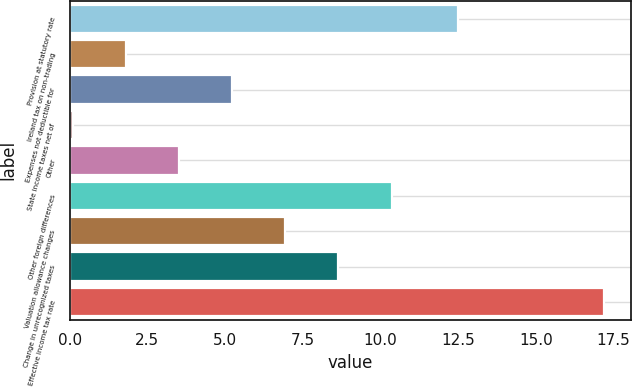<chart> <loc_0><loc_0><loc_500><loc_500><bar_chart><fcel>Provision at statutory rate<fcel>Ireland tax on non-trading<fcel>Expenses not deductible for<fcel>State income taxes net of<fcel>Other<fcel>Other foreign differences<fcel>Valuation allowance changes<fcel>Change in unrecognized taxes<fcel>Effective income tax rate<nl><fcel>12.5<fcel>1.81<fcel>5.23<fcel>0.1<fcel>3.52<fcel>10.36<fcel>6.94<fcel>8.65<fcel>17.2<nl></chart> 